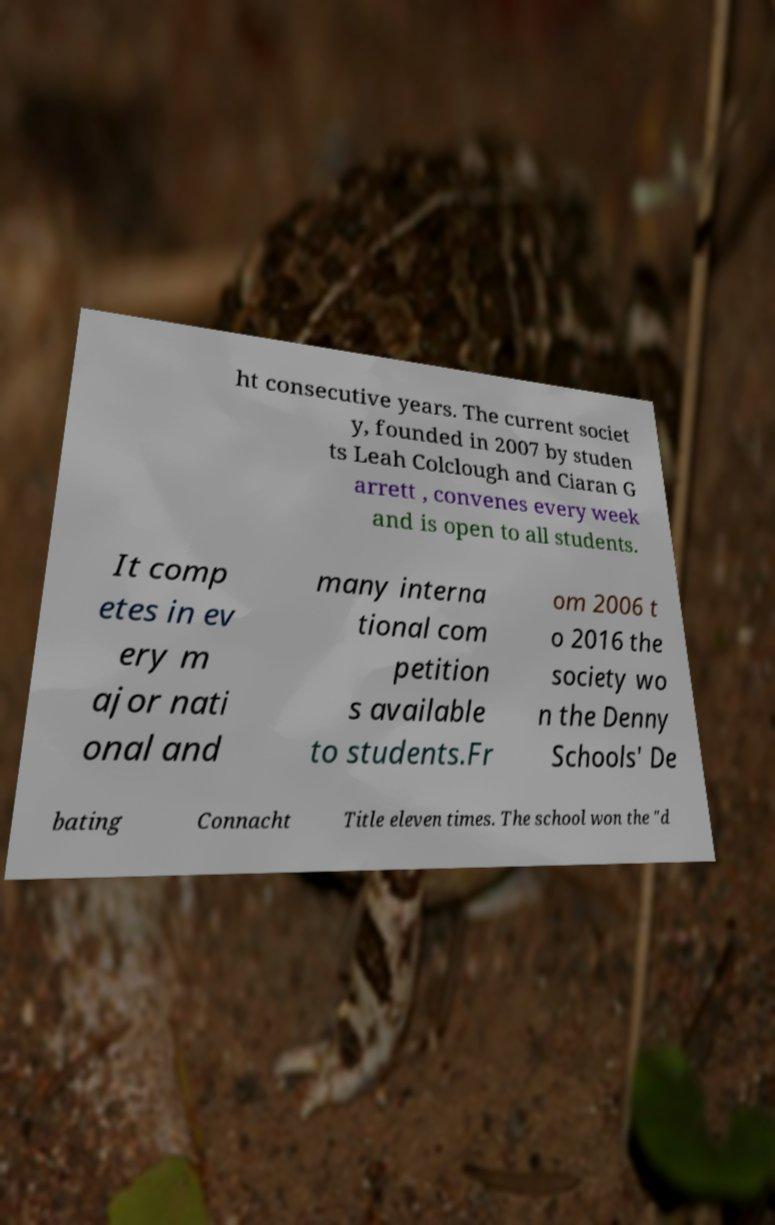Could you assist in decoding the text presented in this image and type it out clearly? ht consecutive years. The current societ y, founded in 2007 by studen ts Leah Colclough and Ciaran G arrett , convenes every week and is open to all students. It comp etes in ev ery m ajor nati onal and many interna tional com petition s available to students.Fr om 2006 t o 2016 the society wo n the Denny Schools' De bating Connacht Title eleven times. The school won the "d 